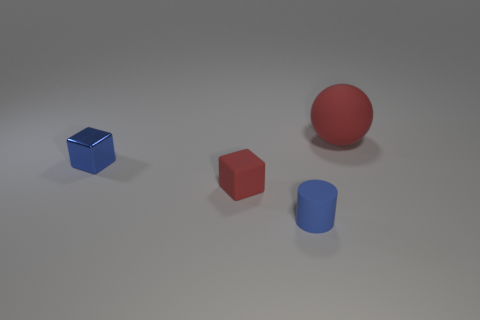Add 4 red blocks. How many objects exist? 8 Subtract all cylinders. How many objects are left? 3 Add 2 cylinders. How many cylinders are left? 3 Add 1 small green matte cylinders. How many small green matte cylinders exist? 1 Subtract 0 cyan blocks. How many objects are left? 4 Subtract all small red objects. Subtract all red matte things. How many objects are left? 1 